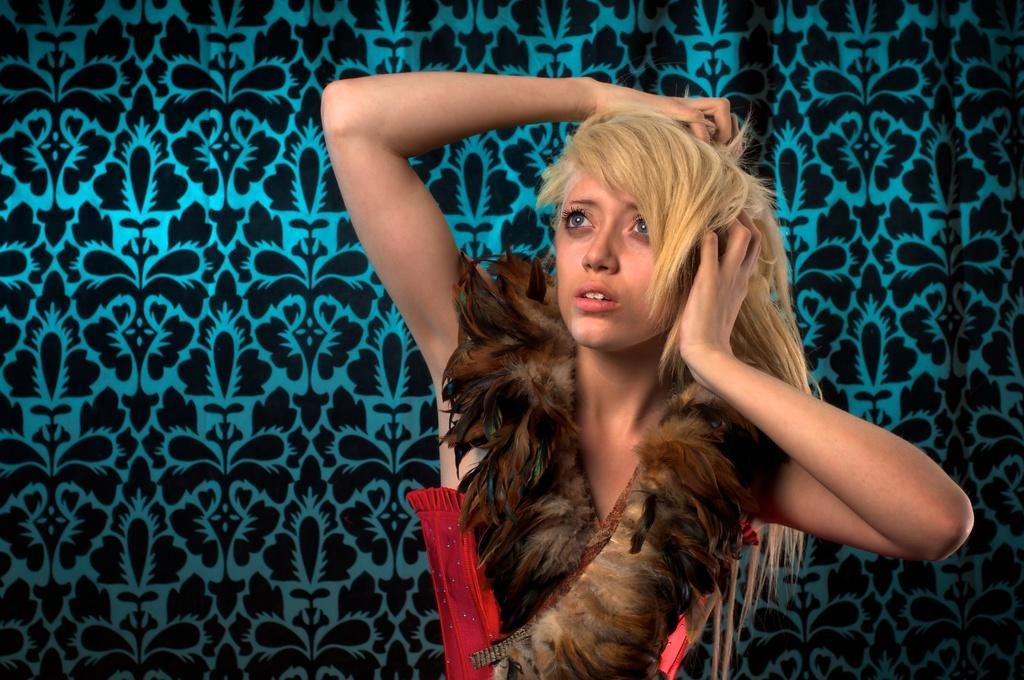Who is the main subject in the image? There is a lady in the center of the image. What is the lady wearing? The lady is wearing a feathered dress. What can be seen in the background of the image? There is a wall in the background of the image. What type of key is used to unlock the machine in the image? There is no machine or key present in the image; it features a lady wearing a feathered dress in the center and a wall in the background. 